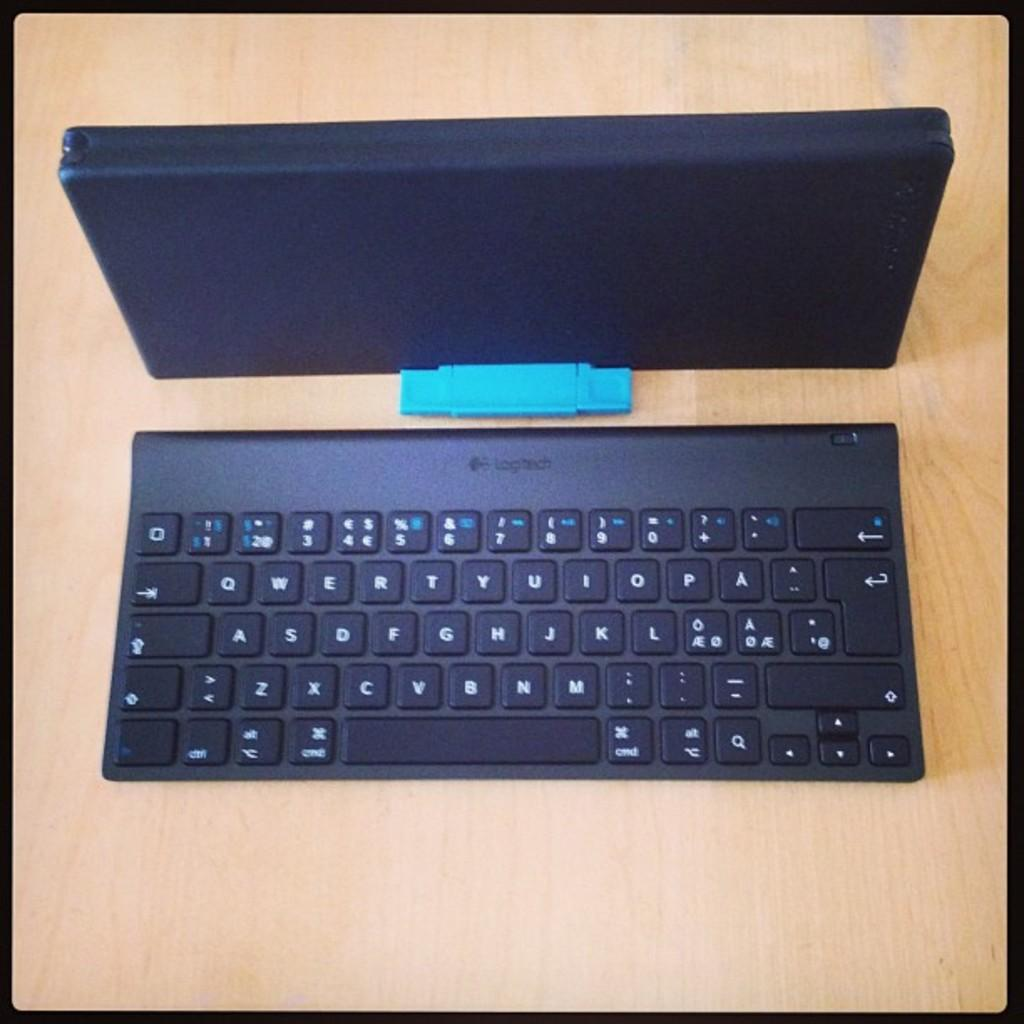<image>
Share a concise interpretation of the image provided. A keypad which has the letter O on the top left. 